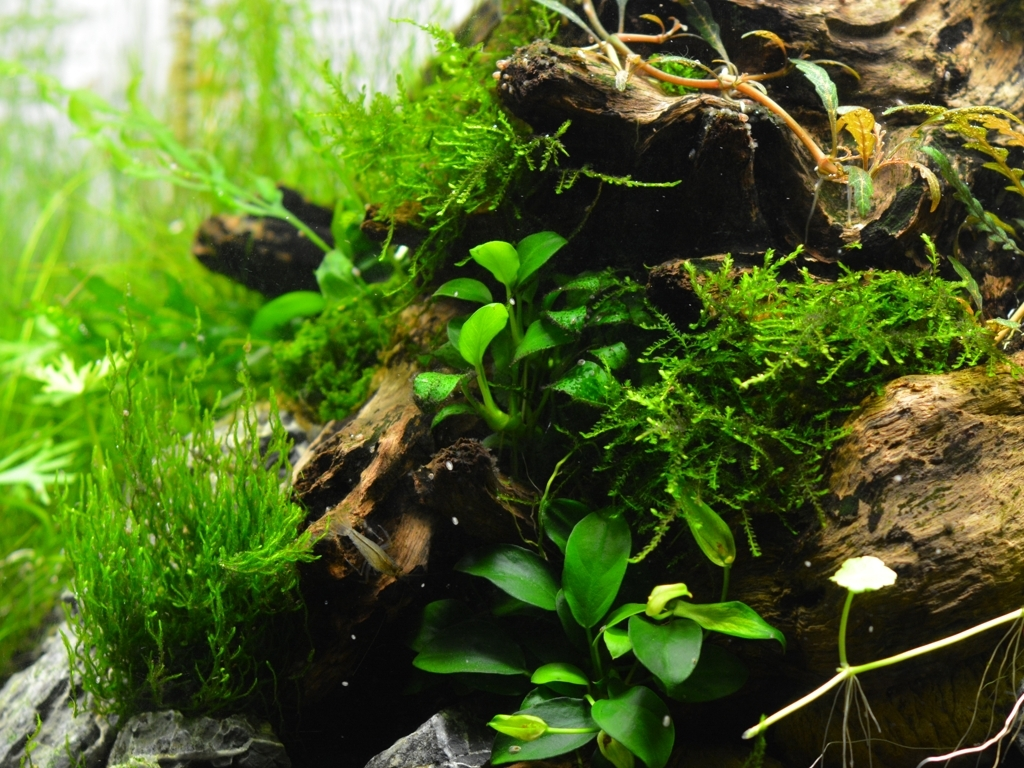Are the features of the main weeds and branches still clear?
A. Yes
B. No
Answer with the option's letter from the given choices directly.
 A. 